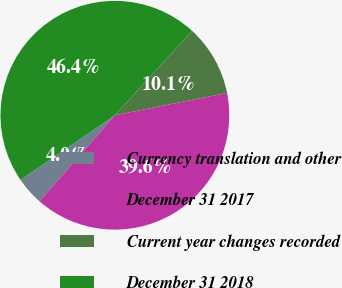<chart> <loc_0><loc_0><loc_500><loc_500><pie_chart><fcel>Currency translation and other<fcel>December 31 2017<fcel>Current year changes recorded<fcel>December 31 2018<nl><fcel>3.99%<fcel>39.57%<fcel>10.07%<fcel>46.37%<nl></chart> 